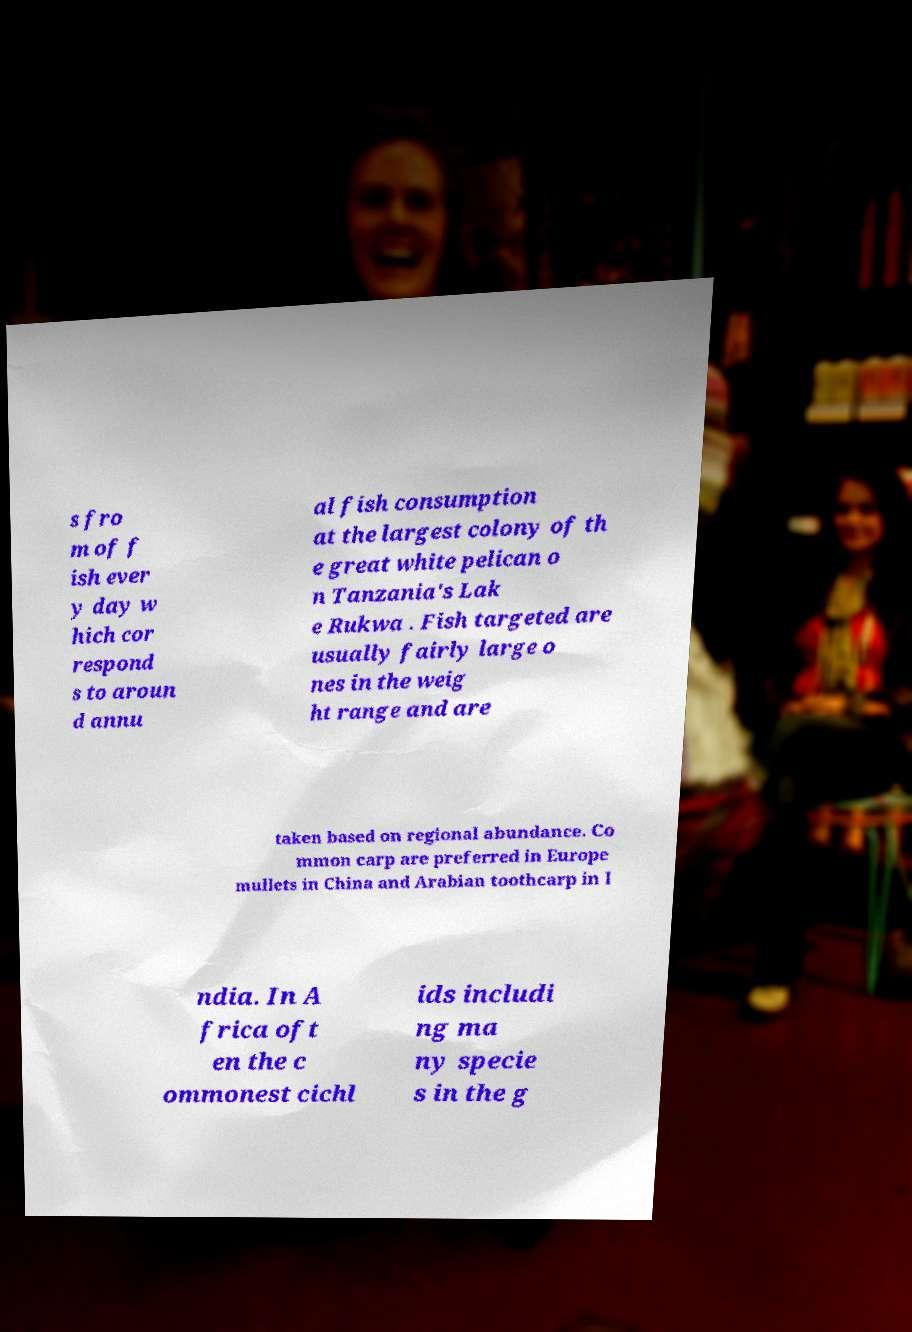For documentation purposes, I need the text within this image transcribed. Could you provide that? s fro m of f ish ever y day w hich cor respond s to aroun d annu al fish consumption at the largest colony of th e great white pelican o n Tanzania's Lak e Rukwa . Fish targeted are usually fairly large o nes in the weig ht range and are taken based on regional abundance. Co mmon carp are preferred in Europe mullets in China and Arabian toothcarp in I ndia. In A frica oft en the c ommonest cichl ids includi ng ma ny specie s in the g 